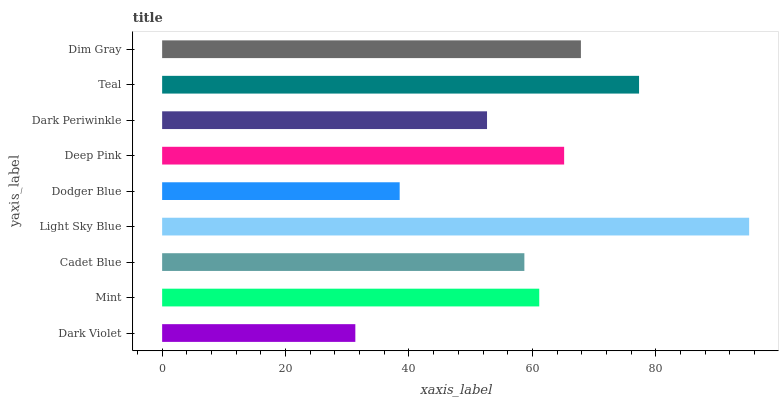Is Dark Violet the minimum?
Answer yes or no. Yes. Is Light Sky Blue the maximum?
Answer yes or no. Yes. Is Mint the minimum?
Answer yes or no. No. Is Mint the maximum?
Answer yes or no. No. Is Mint greater than Dark Violet?
Answer yes or no. Yes. Is Dark Violet less than Mint?
Answer yes or no. Yes. Is Dark Violet greater than Mint?
Answer yes or no. No. Is Mint less than Dark Violet?
Answer yes or no. No. Is Mint the high median?
Answer yes or no. Yes. Is Mint the low median?
Answer yes or no. Yes. Is Dark Periwinkle the high median?
Answer yes or no. No. Is Dark Periwinkle the low median?
Answer yes or no. No. 